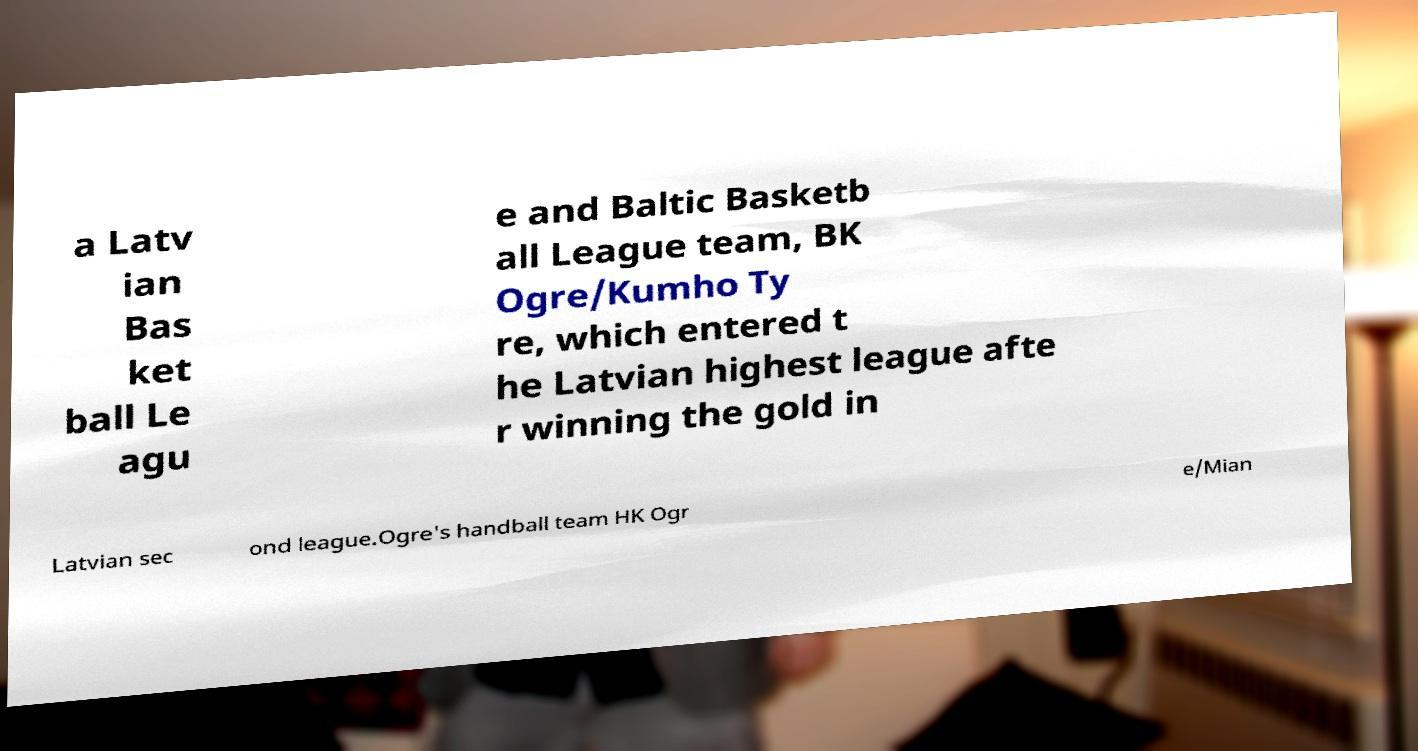There's text embedded in this image that I need extracted. Can you transcribe it verbatim? a Latv ian Bas ket ball Le agu e and Baltic Basketb all League team, BK Ogre/Kumho Ty re, which entered t he Latvian highest league afte r winning the gold in Latvian sec ond league.Ogre's handball team HK Ogr e/Mian 